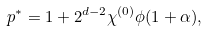<formula> <loc_0><loc_0><loc_500><loc_500>p ^ { * } = 1 + 2 ^ { d - 2 } \chi ^ { ( 0 ) } \phi ( 1 + \alpha ) ,</formula> 